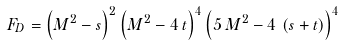<formula> <loc_0><loc_0><loc_500><loc_500>F _ { D } = { \left ( M ^ { 2 } - s \right ) } ^ { 2 } \, { \left ( M ^ { 2 } - 4 \, t \right ) } ^ { 4 } \, { \left ( 5 \, M ^ { 2 } - 4 \, \left ( s + t \right ) \right ) ^ { 4 } }</formula> 